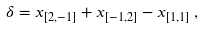<formula> <loc_0><loc_0><loc_500><loc_500>{ \delta } = { x _ { [ 2 , - 1 ] } } + { x _ { [ - 1 , 2 ] } } - { x _ { [ 1 , 1 ] } } \, ,</formula> 